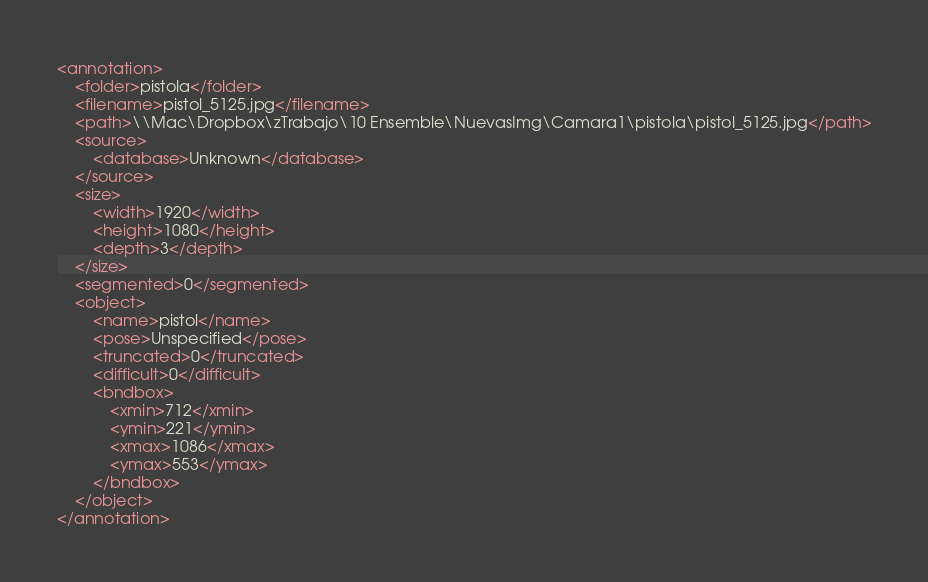Convert code to text. <code><loc_0><loc_0><loc_500><loc_500><_XML_><annotation>
	<folder>pistola</folder>
	<filename>pistol_5125.jpg</filename>
	<path>\\Mac\Dropbox\zTrabajo\10 Ensemble\NuevasImg\Camara1\pistola\pistol_5125.jpg</path>
	<source>
		<database>Unknown</database>
	</source>
	<size>
		<width>1920</width>
		<height>1080</height>
		<depth>3</depth>
	</size>
	<segmented>0</segmented>
	<object>
		<name>pistol</name>
		<pose>Unspecified</pose>
		<truncated>0</truncated>
		<difficult>0</difficult>
		<bndbox>
			<xmin>712</xmin>
			<ymin>221</ymin>
			<xmax>1086</xmax>
			<ymax>553</ymax>
		</bndbox>
	</object>
</annotation>
</code> 